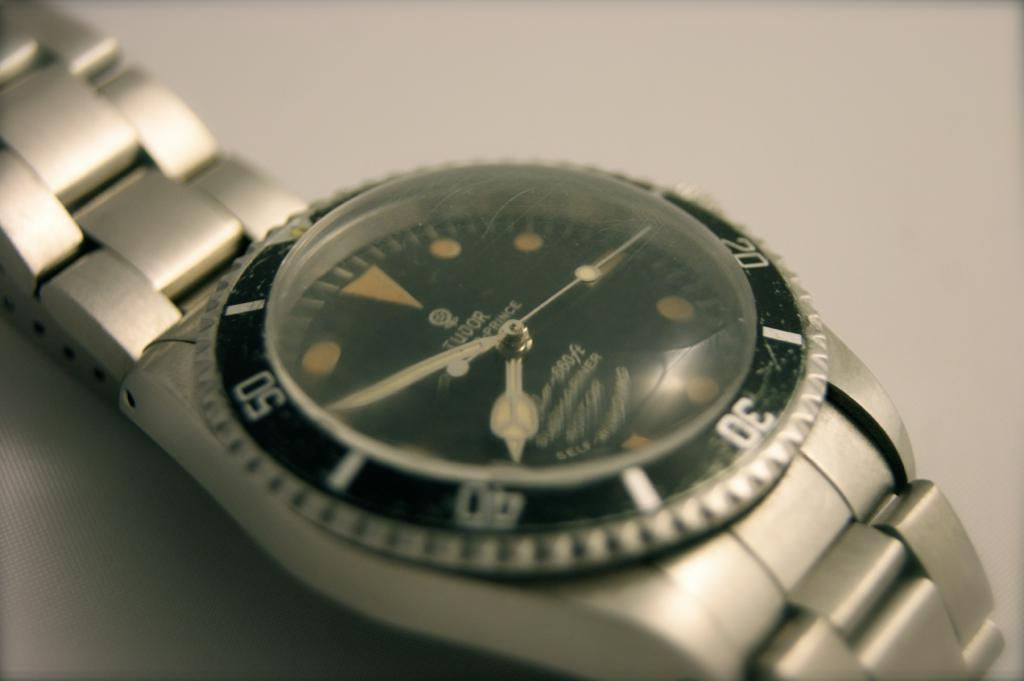<image>
Provide a brief description of the given image. A Tudor watch has a domed glass front. 